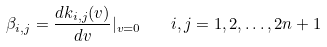<formula> <loc_0><loc_0><loc_500><loc_500>\beta _ { i , j } = \frac { d k _ { i , j } ( v ) } { d v } | _ { v = 0 } \quad i , j = 1 , 2 , \dots , 2 n + 1</formula> 